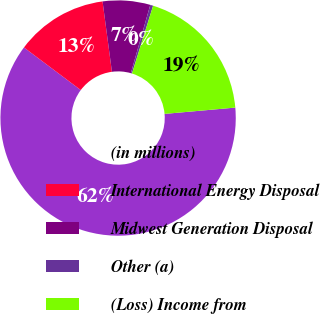Convert chart to OTSL. <chart><loc_0><loc_0><loc_500><loc_500><pie_chart><fcel>(in millions)<fcel>International Energy Disposal<fcel>Midwest Generation Disposal<fcel>Other (a)<fcel>(Loss) Income from<nl><fcel>61.65%<fcel>12.65%<fcel>6.52%<fcel>0.4%<fcel>18.77%<nl></chart> 